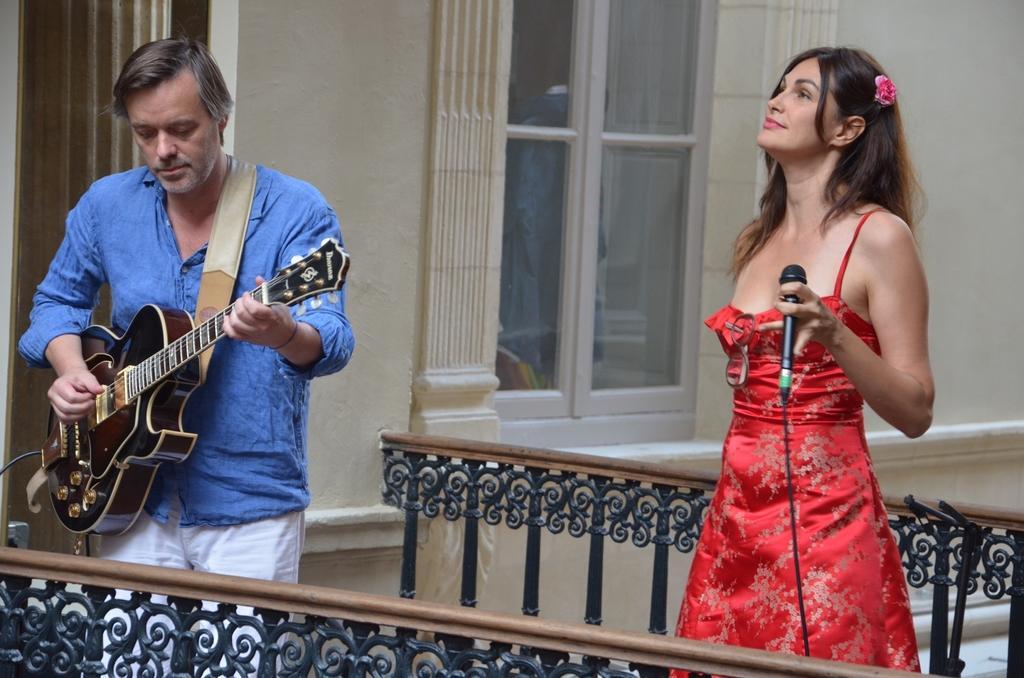Describe this image in one or two sentences. The person wearing blue shirt is playing guitar and the women behind him is holding a mic. 